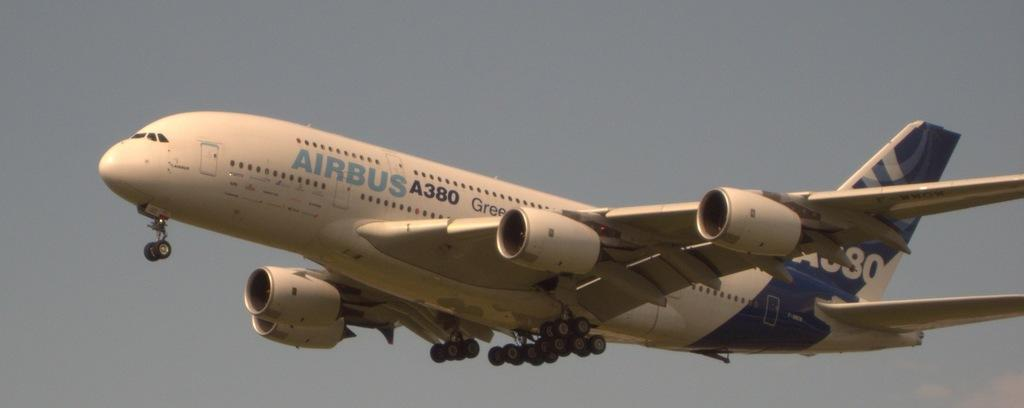<image>
Provide a brief description of the given image. A white airplane in the sky named Airbus 